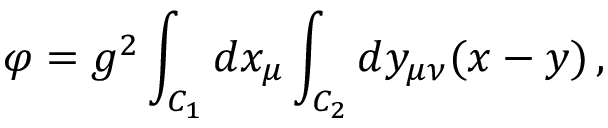<formula> <loc_0><loc_0><loc_500><loc_500>\varphi = g ^ { 2 } \int _ { C _ { 1 } } d x _ { \mu } \int _ { C _ { 2 } } d y _ { \mu \nu } ( x - y ) \, ,</formula> 